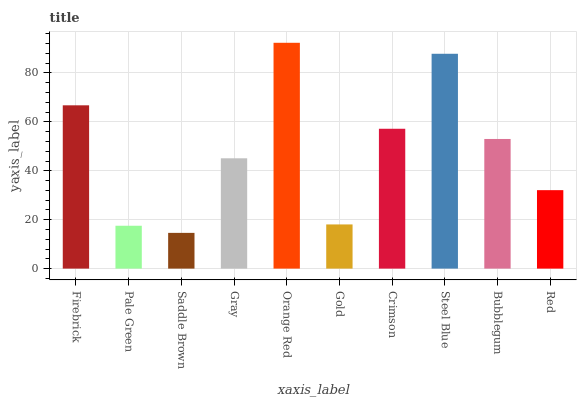Is Saddle Brown the minimum?
Answer yes or no. Yes. Is Orange Red the maximum?
Answer yes or no. Yes. Is Pale Green the minimum?
Answer yes or no. No. Is Pale Green the maximum?
Answer yes or no. No. Is Firebrick greater than Pale Green?
Answer yes or no. Yes. Is Pale Green less than Firebrick?
Answer yes or no. Yes. Is Pale Green greater than Firebrick?
Answer yes or no. No. Is Firebrick less than Pale Green?
Answer yes or no. No. Is Bubblegum the high median?
Answer yes or no. Yes. Is Gray the low median?
Answer yes or no. Yes. Is Orange Red the high median?
Answer yes or no. No. Is Firebrick the low median?
Answer yes or no. No. 